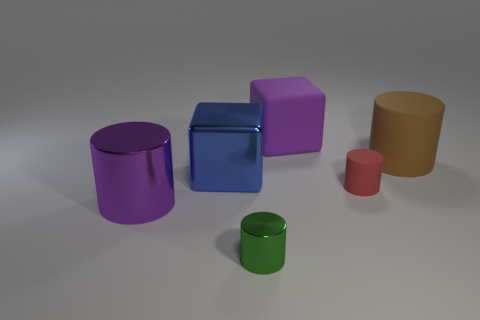Is the number of metal cubes to the right of the tiny metallic cylinder the same as the number of big shiny things?
Offer a very short reply. No. There is a shiny cylinder that is the same color as the rubber cube; what size is it?
Provide a succinct answer. Large. Is there a large block that has the same material as the green object?
Keep it short and to the point. Yes. There is a tiny thing that is in front of the purple shiny thing; is its shape the same as the tiny thing right of the tiny metal object?
Offer a terse response. Yes. Are any big gray metallic balls visible?
Your answer should be very brief. No. The other thing that is the same size as the green metal thing is what color?
Give a very brief answer. Red. How many small gray things are the same shape as the red rubber object?
Keep it short and to the point. 0. Do the big object that is behind the large brown thing and the brown object have the same material?
Your answer should be very brief. Yes. How many cylinders are rubber objects or red rubber objects?
Make the answer very short. 2. There is a purple thing that is to the right of the small shiny cylinder left of the big rubber object in front of the big purple rubber block; what shape is it?
Provide a succinct answer. Cube. 